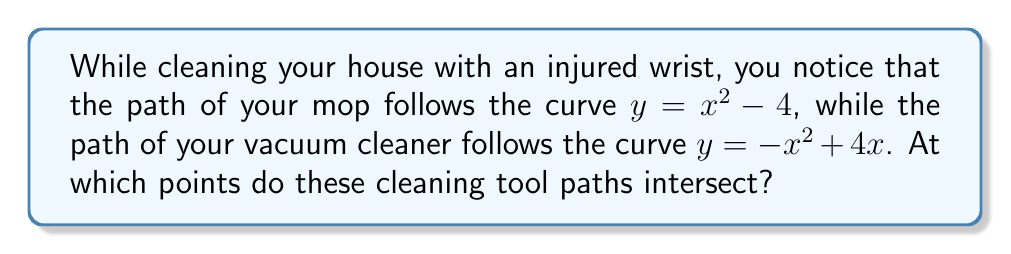Can you solve this math problem? To find the intersection points of these two curves, we need to solve the equation:

$x^2 - 4 = -x^2 + 4x$

Step 1: Add $x^2$ to both sides of the equation:
$2x^2 - 4 = 4x$

Step 2: Subtract 4x from both sides:
$2x^2 - 4x - 4 = 0$

Step 3: This is a quadratic equation. We can solve it using the quadratic formula:
$x = \frac{-b \pm \sqrt{b^2 - 4ac}}{2a}$

Where $a = 2$, $b = -4$, and $c = -4$

Step 4: Substitute these values into the quadratic formula:
$x = \frac{4 \pm \sqrt{(-4)^2 - 4(2)(-4)}}{2(2)}$
$= \frac{4 \pm \sqrt{16 + 32}}{4}$
$= \frac{4 \pm \sqrt{48}}{4}$
$= \frac{4 \pm 4\sqrt{3}}{4}$
$= 1 \pm \sqrt{3}$

Step 5: Therefore, the x-coordinates of the intersection points are:
$x_1 = 1 + \sqrt{3}$ and $x_2 = 1 - \sqrt{3}$

Step 6: To find the y-coordinates, substitute these x-values into either of the original equations. Let's use $y = x^2 - 4$:

For $x_1$: $y_1 = (1 + \sqrt{3})^2 - 4 = 1 + 2\sqrt{3} + 3 - 4 = 2\sqrt{3}$
For $x_2$: $y_2 = (1 - \sqrt{3})^2 - 4 = 1 - 2\sqrt{3} + 3 - 4 = -2\sqrt{3}$

Therefore, the intersection points are $(1 + \sqrt{3}, 2\sqrt{3})$ and $(1 - \sqrt{3}, -2\sqrt{3})$.
Answer: $(1 + \sqrt{3}, 2\sqrt{3})$ and $(1 - \sqrt{3}, -2\sqrt{3})$ 